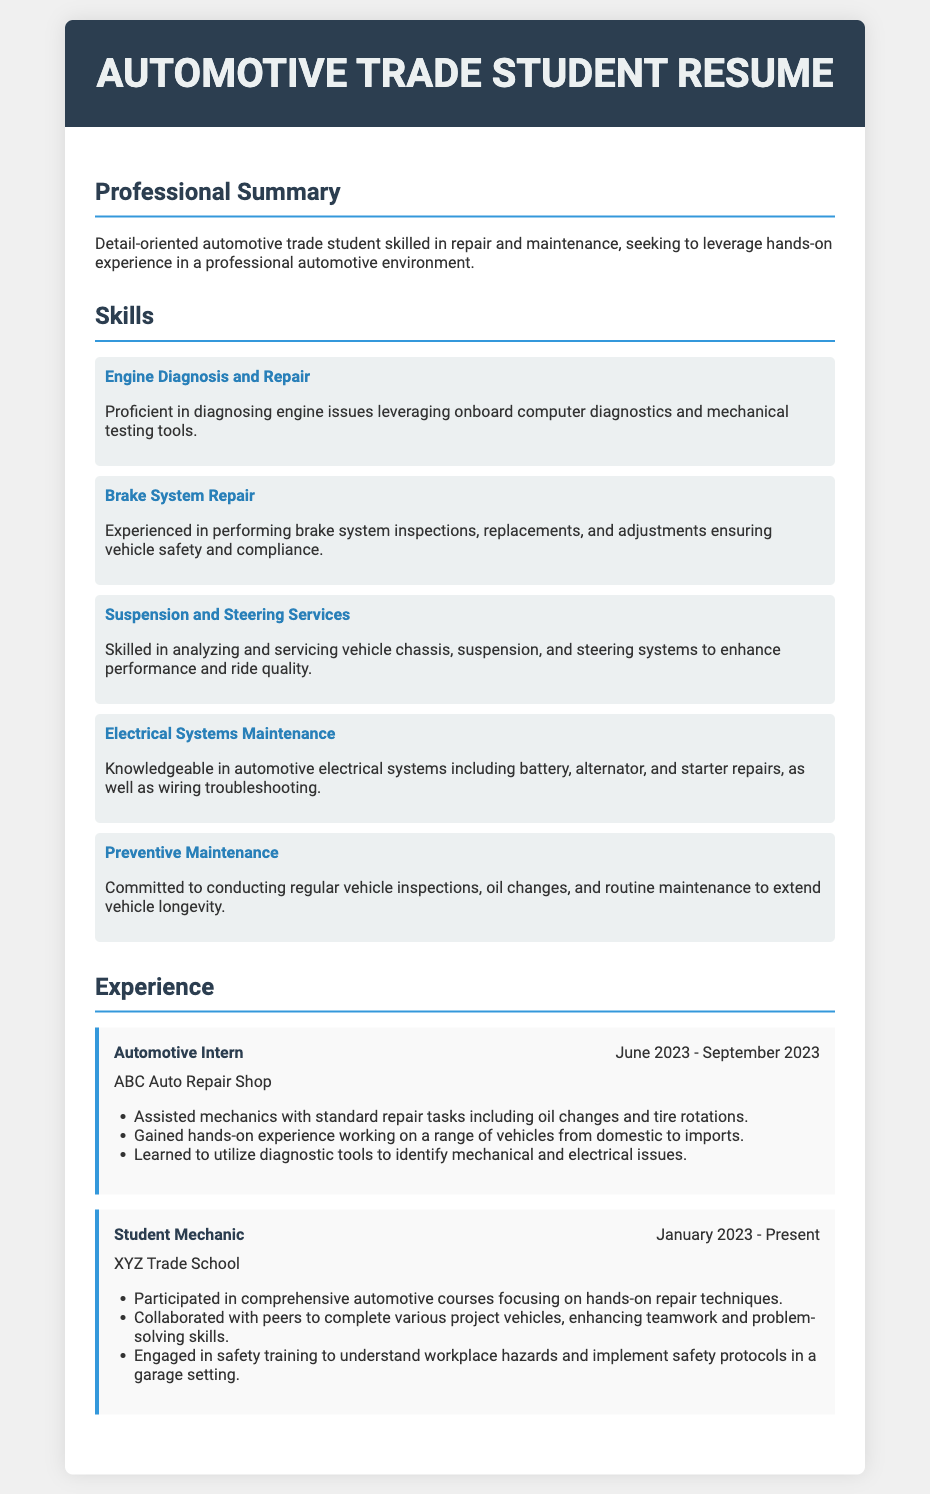what is the title of the document? The title of the document is specified in the <title> tag in the HTML code.
Answer: Automotive Trade Student Resume what skills are highlighted in the resume? The skills listed under the Skills section provide an overview of the competencies of the individual.
Answer: Engine Diagnosis and Repair, Brake System Repair, Suspension and Steering Services, Electrical Systems Maintenance, Preventive Maintenance who was the automotive intern with? The experience section gives the name of the organization where the intern worked.
Answer: ABC Auto Repair Shop when did the student mechanic role start? The start date for the student mechanic position is mentioned in the experience section.
Answer: January 2023 what is the main focus of the professional summary? The professional summary provides insight into the individual's objectives and capabilities.
Answer: Repair and maintenance which tools did the intern learn to utilize? The document mentions learning about specific tools in the experience section.
Answer: Diagnostic tools how long did the automotive internship last? The duration of the internship is specified within the experience section.
Answer: 3 months what is one responsibility of the student mechanic? The experience section outlines roles and duties associated with each position held.
Answer: Participated in comprehensive automotive courses what is one benefit of preventive maintenance according to the resume? The preventive maintenance section lists advantages associated with routine upkeep of vehicles.
Answer: Extend vehicle longevity 